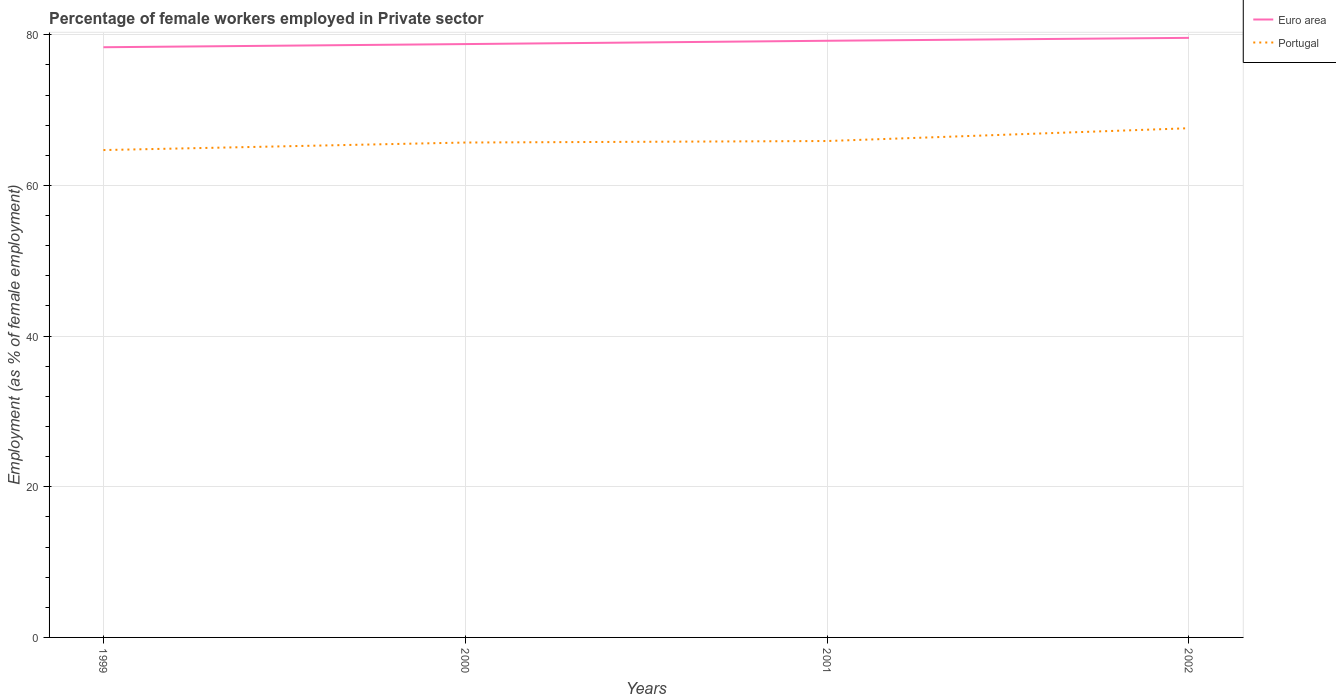Is the number of lines equal to the number of legend labels?
Offer a very short reply. Yes. Across all years, what is the maximum percentage of females employed in Private sector in Euro area?
Give a very brief answer. 78.35. In which year was the percentage of females employed in Private sector in Euro area maximum?
Provide a short and direct response. 1999. What is the difference between the highest and the second highest percentage of females employed in Private sector in Portugal?
Provide a succinct answer. 2.9. Is the percentage of females employed in Private sector in Portugal strictly greater than the percentage of females employed in Private sector in Euro area over the years?
Provide a short and direct response. Yes. How many lines are there?
Make the answer very short. 2. Are the values on the major ticks of Y-axis written in scientific E-notation?
Give a very brief answer. No. Does the graph contain grids?
Make the answer very short. Yes. Where does the legend appear in the graph?
Your response must be concise. Top right. How many legend labels are there?
Your response must be concise. 2. What is the title of the graph?
Your answer should be compact. Percentage of female workers employed in Private sector. What is the label or title of the X-axis?
Offer a very short reply. Years. What is the label or title of the Y-axis?
Keep it short and to the point. Employment (as % of female employment). What is the Employment (as % of female employment) of Euro area in 1999?
Your answer should be very brief. 78.35. What is the Employment (as % of female employment) of Portugal in 1999?
Make the answer very short. 64.7. What is the Employment (as % of female employment) of Euro area in 2000?
Offer a terse response. 78.77. What is the Employment (as % of female employment) of Portugal in 2000?
Offer a terse response. 65.7. What is the Employment (as % of female employment) of Euro area in 2001?
Keep it short and to the point. 79.21. What is the Employment (as % of female employment) in Portugal in 2001?
Offer a very short reply. 65.9. What is the Employment (as % of female employment) in Euro area in 2002?
Offer a terse response. 79.6. What is the Employment (as % of female employment) of Portugal in 2002?
Give a very brief answer. 67.6. Across all years, what is the maximum Employment (as % of female employment) of Euro area?
Your response must be concise. 79.6. Across all years, what is the maximum Employment (as % of female employment) of Portugal?
Provide a succinct answer. 67.6. Across all years, what is the minimum Employment (as % of female employment) of Euro area?
Keep it short and to the point. 78.35. Across all years, what is the minimum Employment (as % of female employment) in Portugal?
Offer a terse response. 64.7. What is the total Employment (as % of female employment) in Euro area in the graph?
Your answer should be very brief. 315.93. What is the total Employment (as % of female employment) of Portugal in the graph?
Your response must be concise. 263.9. What is the difference between the Employment (as % of female employment) in Euro area in 1999 and that in 2000?
Provide a succinct answer. -0.42. What is the difference between the Employment (as % of female employment) of Portugal in 1999 and that in 2000?
Keep it short and to the point. -1. What is the difference between the Employment (as % of female employment) of Euro area in 1999 and that in 2001?
Offer a terse response. -0.86. What is the difference between the Employment (as % of female employment) in Euro area in 1999 and that in 2002?
Your answer should be compact. -1.24. What is the difference between the Employment (as % of female employment) in Portugal in 1999 and that in 2002?
Offer a terse response. -2.9. What is the difference between the Employment (as % of female employment) of Euro area in 2000 and that in 2001?
Keep it short and to the point. -0.44. What is the difference between the Employment (as % of female employment) in Euro area in 2000 and that in 2002?
Ensure brevity in your answer.  -0.82. What is the difference between the Employment (as % of female employment) of Euro area in 2001 and that in 2002?
Your answer should be compact. -0.39. What is the difference between the Employment (as % of female employment) of Euro area in 1999 and the Employment (as % of female employment) of Portugal in 2000?
Offer a very short reply. 12.65. What is the difference between the Employment (as % of female employment) in Euro area in 1999 and the Employment (as % of female employment) in Portugal in 2001?
Offer a very short reply. 12.45. What is the difference between the Employment (as % of female employment) of Euro area in 1999 and the Employment (as % of female employment) of Portugal in 2002?
Your answer should be compact. 10.75. What is the difference between the Employment (as % of female employment) of Euro area in 2000 and the Employment (as % of female employment) of Portugal in 2001?
Provide a short and direct response. 12.87. What is the difference between the Employment (as % of female employment) of Euro area in 2000 and the Employment (as % of female employment) of Portugal in 2002?
Your response must be concise. 11.17. What is the difference between the Employment (as % of female employment) of Euro area in 2001 and the Employment (as % of female employment) of Portugal in 2002?
Provide a short and direct response. 11.61. What is the average Employment (as % of female employment) of Euro area per year?
Make the answer very short. 78.98. What is the average Employment (as % of female employment) of Portugal per year?
Ensure brevity in your answer.  65.97. In the year 1999, what is the difference between the Employment (as % of female employment) of Euro area and Employment (as % of female employment) of Portugal?
Offer a very short reply. 13.65. In the year 2000, what is the difference between the Employment (as % of female employment) of Euro area and Employment (as % of female employment) of Portugal?
Your response must be concise. 13.07. In the year 2001, what is the difference between the Employment (as % of female employment) of Euro area and Employment (as % of female employment) of Portugal?
Your answer should be very brief. 13.31. In the year 2002, what is the difference between the Employment (as % of female employment) in Euro area and Employment (as % of female employment) in Portugal?
Offer a very short reply. 12. What is the ratio of the Employment (as % of female employment) in Portugal in 1999 to that in 2000?
Offer a very short reply. 0.98. What is the ratio of the Employment (as % of female employment) in Portugal in 1999 to that in 2001?
Your answer should be very brief. 0.98. What is the ratio of the Employment (as % of female employment) in Euro area in 1999 to that in 2002?
Keep it short and to the point. 0.98. What is the ratio of the Employment (as % of female employment) in Portugal in 1999 to that in 2002?
Your answer should be very brief. 0.96. What is the ratio of the Employment (as % of female employment) of Euro area in 2000 to that in 2002?
Your answer should be very brief. 0.99. What is the ratio of the Employment (as % of female employment) of Portugal in 2000 to that in 2002?
Give a very brief answer. 0.97. What is the ratio of the Employment (as % of female employment) of Portugal in 2001 to that in 2002?
Provide a succinct answer. 0.97. What is the difference between the highest and the second highest Employment (as % of female employment) of Euro area?
Keep it short and to the point. 0.39. What is the difference between the highest and the second highest Employment (as % of female employment) in Portugal?
Keep it short and to the point. 1.7. What is the difference between the highest and the lowest Employment (as % of female employment) in Euro area?
Give a very brief answer. 1.24. What is the difference between the highest and the lowest Employment (as % of female employment) in Portugal?
Give a very brief answer. 2.9. 